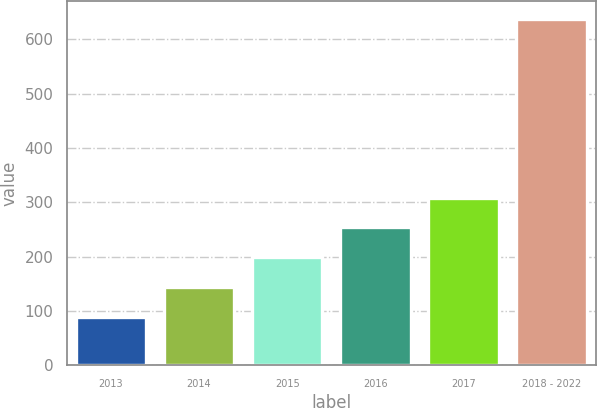Convert chart to OTSL. <chart><loc_0><loc_0><loc_500><loc_500><bar_chart><fcel>2013<fcel>2014<fcel>2015<fcel>2016<fcel>2017<fcel>2018 - 2022<nl><fcel>89.6<fcel>144.46<fcel>199.32<fcel>254.18<fcel>309.04<fcel>638.2<nl></chart> 